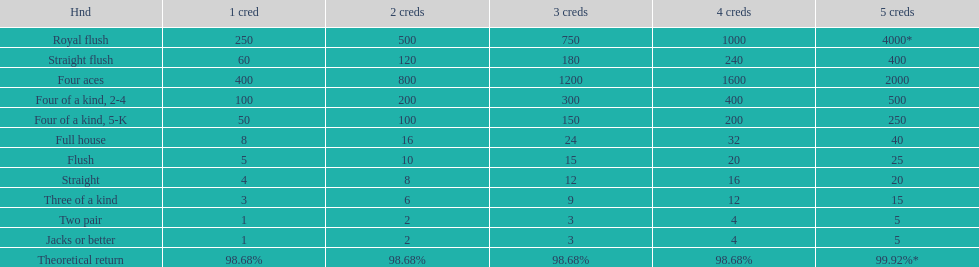Parse the full table. {'header': ['Hnd', '1 cred', '2 creds', '3 creds', '4 creds', '5 creds'], 'rows': [['Royal flush', '250', '500', '750', '1000', '4000*'], ['Straight flush', '60', '120', '180', '240', '400'], ['Four aces', '400', '800', '1200', '1600', '2000'], ['Four of a kind, 2-4', '100', '200', '300', '400', '500'], ['Four of a kind, 5-K', '50', '100', '150', '200', '250'], ['Full house', '8', '16', '24', '32', '40'], ['Flush', '5', '10', '15', '20', '25'], ['Straight', '4', '8', '12', '16', '20'], ['Three of a kind', '3', '6', '9', '12', '15'], ['Two pair', '1', '2', '3', '4', '5'], ['Jacks or better', '1', '2', '3', '4', '5'], ['Theoretical return', '98.68%', '98.68%', '98.68%', '98.68%', '99.92%*']]} The number of flush wins at one credit to equal one flush win at 5 credits. 5. 